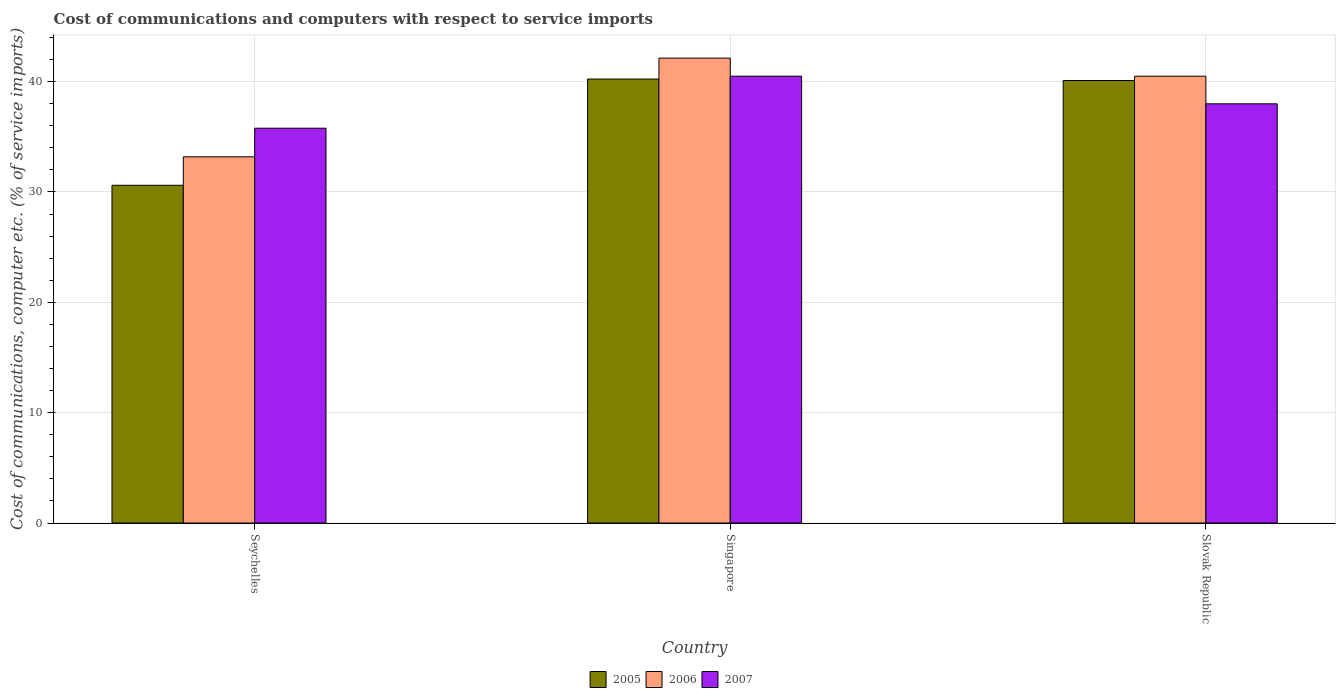How many bars are there on the 3rd tick from the left?
Offer a terse response. 3. How many bars are there on the 2nd tick from the right?
Offer a very short reply. 3. What is the label of the 3rd group of bars from the left?
Your response must be concise. Slovak Republic. What is the cost of communications and computers in 2006 in Singapore?
Your answer should be compact. 42.13. Across all countries, what is the maximum cost of communications and computers in 2005?
Make the answer very short. 40.24. Across all countries, what is the minimum cost of communications and computers in 2005?
Offer a very short reply. 30.61. In which country was the cost of communications and computers in 2007 maximum?
Offer a terse response. Singapore. In which country was the cost of communications and computers in 2007 minimum?
Ensure brevity in your answer.  Seychelles. What is the total cost of communications and computers in 2007 in the graph?
Your answer should be compact. 114.26. What is the difference between the cost of communications and computers in 2006 in Singapore and that in Slovak Republic?
Your answer should be compact. 1.64. What is the difference between the cost of communications and computers in 2005 in Slovak Republic and the cost of communications and computers in 2007 in Seychelles?
Provide a succinct answer. 4.32. What is the average cost of communications and computers in 2006 per country?
Your response must be concise. 38.6. What is the difference between the cost of communications and computers of/in 2007 and cost of communications and computers of/in 2005 in Seychelles?
Offer a very short reply. 5.17. What is the ratio of the cost of communications and computers in 2005 in Seychelles to that in Singapore?
Your answer should be very brief. 0.76. Is the cost of communications and computers in 2005 in Seychelles less than that in Singapore?
Offer a very short reply. Yes. Is the difference between the cost of communications and computers in 2007 in Seychelles and Slovak Republic greater than the difference between the cost of communications and computers in 2005 in Seychelles and Slovak Republic?
Your response must be concise. Yes. What is the difference between the highest and the second highest cost of communications and computers in 2005?
Offer a very short reply. 0.13. What is the difference between the highest and the lowest cost of communications and computers in 2007?
Keep it short and to the point. 4.71. Is the sum of the cost of communications and computers in 2007 in Singapore and Slovak Republic greater than the maximum cost of communications and computers in 2006 across all countries?
Provide a short and direct response. Yes. What does the 2nd bar from the left in Seychelles represents?
Offer a very short reply. 2006. What does the 3rd bar from the right in Seychelles represents?
Keep it short and to the point. 2005. Is it the case that in every country, the sum of the cost of communications and computers in 2005 and cost of communications and computers in 2007 is greater than the cost of communications and computers in 2006?
Offer a very short reply. Yes. How many bars are there?
Offer a terse response. 9. Does the graph contain any zero values?
Provide a short and direct response. No. How many legend labels are there?
Keep it short and to the point. 3. What is the title of the graph?
Keep it short and to the point. Cost of communications and computers with respect to service imports. Does "2005" appear as one of the legend labels in the graph?
Provide a short and direct response. Yes. What is the label or title of the X-axis?
Offer a very short reply. Country. What is the label or title of the Y-axis?
Provide a short and direct response. Cost of communications, computer etc. (% of service imports). What is the Cost of communications, computer etc. (% of service imports) of 2005 in Seychelles?
Provide a succinct answer. 30.61. What is the Cost of communications, computer etc. (% of service imports) of 2006 in Seychelles?
Keep it short and to the point. 33.19. What is the Cost of communications, computer etc. (% of service imports) of 2007 in Seychelles?
Your response must be concise. 35.78. What is the Cost of communications, computer etc. (% of service imports) in 2005 in Singapore?
Keep it short and to the point. 40.24. What is the Cost of communications, computer etc. (% of service imports) of 2006 in Singapore?
Your answer should be compact. 42.13. What is the Cost of communications, computer etc. (% of service imports) of 2007 in Singapore?
Keep it short and to the point. 40.49. What is the Cost of communications, computer etc. (% of service imports) in 2005 in Slovak Republic?
Provide a short and direct response. 40.1. What is the Cost of communications, computer etc. (% of service imports) in 2006 in Slovak Republic?
Make the answer very short. 40.49. What is the Cost of communications, computer etc. (% of service imports) in 2007 in Slovak Republic?
Your answer should be very brief. 37.99. Across all countries, what is the maximum Cost of communications, computer etc. (% of service imports) in 2005?
Your answer should be very brief. 40.24. Across all countries, what is the maximum Cost of communications, computer etc. (% of service imports) of 2006?
Offer a very short reply. 42.13. Across all countries, what is the maximum Cost of communications, computer etc. (% of service imports) in 2007?
Your answer should be very brief. 40.49. Across all countries, what is the minimum Cost of communications, computer etc. (% of service imports) of 2005?
Provide a short and direct response. 30.61. Across all countries, what is the minimum Cost of communications, computer etc. (% of service imports) of 2006?
Your answer should be compact. 33.19. Across all countries, what is the minimum Cost of communications, computer etc. (% of service imports) in 2007?
Keep it short and to the point. 35.78. What is the total Cost of communications, computer etc. (% of service imports) in 2005 in the graph?
Provide a short and direct response. 110.95. What is the total Cost of communications, computer etc. (% of service imports) in 2006 in the graph?
Your response must be concise. 115.81. What is the total Cost of communications, computer etc. (% of service imports) in 2007 in the graph?
Provide a succinct answer. 114.26. What is the difference between the Cost of communications, computer etc. (% of service imports) in 2005 in Seychelles and that in Singapore?
Your answer should be compact. -9.63. What is the difference between the Cost of communications, computer etc. (% of service imports) in 2006 in Seychelles and that in Singapore?
Your answer should be very brief. -8.94. What is the difference between the Cost of communications, computer etc. (% of service imports) in 2007 in Seychelles and that in Singapore?
Offer a terse response. -4.71. What is the difference between the Cost of communications, computer etc. (% of service imports) of 2005 in Seychelles and that in Slovak Republic?
Your answer should be compact. -9.49. What is the difference between the Cost of communications, computer etc. (% of service imports) in 2006 in Seychelles and that in Slovak Republic?
Offer a very short reply. -7.3. What is the difference between the Cost of communications, computer etc. (% of service imports) of 2007 in Seychelles and that in Slovak Republic?
Keep it short and to the point. -2.21. What is the difference between the Cost of communications, computer etc. (% of service imports) of 2005 in Singapore and that in Slovak Republic?
Your response must be concise. 0.13. What is the difference between the Cost of communications, computer etc. (% of service imports) in 2006 in Singapore and that in Slovak Republic?
Your answer should be very brief. 1.64. What is the difference between the Cost of communications, computer etc. (% of service imports) in 2007 in Singapore and that in Slovak Republic?
Your answer should be very brief. 2.5. What is the difference between the Cost of communications, computer etc. (% of service imports) of 2005 in Seychelles and the Cost of communications, computer etc. (% of service imports) of 2006 in Singapore?
Make the answer very short. -11.52. What is the difference between the Cost of communications, computer etc. (% of service imports) in 2005 in Seychelles and the Cost of communications, computer etc. (% of service imports) in 2007 in Singapore?
Keep it short and to the point. -9.89. What is the difference between the Cost of communications, computer etc. (% of service imports) of 2006 in Seychelles and the Cost of communications, computer etc. (% of service imports) of 2007 in Singapore?
Offer a terse response. -7.31. What is the difference between the Cost of communications, computer etc. (% of service imports) in 2005 in Seychelles and the Cost of communications, computer etc. (% of service imports) in 2006 in Slovak Republic?
Offer a very short reply. -9.88. What is the difference between the Cost of communications, computer etc. (% of service imports) of 2005 in Seychelles and the Cost of communications, computer etc. (% of service imports) of 2007 in Slovak Republic?
Keep it short and to the point. -7.38. What is the difference between the Cost of communications, computer etc. (% of service imports) in 2006 in Seychelles and the Cost of communications, computer etc. (% of service imports) in 2007 in Slovak Republic?
Your answer should be very brief. -4.8. What is the difference between the Cost of communications, computer etc. (% of service imports) of 2005 in Singapore and the Cost of communications, computer etc. (% of service imports) of 2006 in Slovak Republic?
Ensure brevity in your answer.  -0.25. What is the difference between the Cost of communications, computer etc. (% of service imports) in 2005 in Singapore and the Cost of communications, computer etc. (% of service imports) in 2007 in Slovak Republic?
Make the answer very short. 2.25. What is the difference between the Cost of communications, computer etc. (% of service imports) of 2006 in Singapore and the Cost of communications, computer etc. (% of service imports) of 2007 in Slovak Republic?
Your response must be concise. 4.14. What is the average Cost of communications, computer etc. (% of service imports) in 2005 per country?
Keep it short and to the point. 36.98. What is the average Cost of communications, computer etc. (% of service imports) in 2006 per country?
Your answer should be very brief. 38.6. What is the average Cost of communications, computer etc. (% of service imports) in 2007 per country?
Provide a short and direct response. 38.09. What is the difference between the Cost of communications, computer etc. (% of service imports) in 2005 and Cost of communications, computer etc. (% of service imports) in 2006 in Seychelles?
Ensure brevity in your answer.  -2.58. What is the difference between the Cost of communications, computer etc. (% of service imports) in 2005 and Cost of communications, computer etc. (% of service imports) in 2007 in Seychelles?
Ensure brevity in your answer.  -5.17. What is the difference between the Cost of communications, computer etc. (% of service imports) of 2006 and Cost of communications, computer etc. (% of service imports) of 2007 in Seychelles?
Keep it short and to the point. -2.59. What is the difference between the Cost of communications, computer etc. (% of service imports) of 2005 and Cost of communications, computer etc. (% of service imports) of 2006 in Singapore?
Provide a succinct answer. -1.89. What is the difference between the Cost of communications, computer etc. (% of service imports) of 2005 and Cost of communications, computer etc. (% of service imports) of 2007 in Singapore?
Keep it short and to the point. -0.26. What is the difference between the Cost of communications, computer etc. (% of service imports) of 2006 and Cost of communications, computer etc. (% of service imports) of 2007 in Singapore?
Keep it short and to the point. 1.64. What is the difference between the Cost of communications, computer etc. (% of service imports) of 2005 and Cost of communications, computer etc. (% of service imports) of 2006 in Slovak Republic?
Keep it short and to the point. -0.39. What is the difference between the Cost of communications, computer etc. (% of service imports) in 2005 and Cost of communications, computer etc. (% of service imports) in 2007 in Slovak Republic?
Give a very brief answer. 2.11. What is the difference between the Cost of communications, computer etc. (% of service imports) of 2006 and Cost of communications, computer etc. (% of service imports) of 2007 in Slovak Republic?
Provide a succinct answer. 2.5. What is the ratio of the Cost of communications, computer etc. (% of service imports) in 2005 in Seychelles to that in Singapore?
Provide a succinct answer. 0.76. What is the ratio of the Cost of communications, computer etc. (% of service imports) of 2006 in Seychelles to that in Singapore?
Provide a short and direct response. 0.79. What is the ratio of the Cost of communications, computer etc. (% of service imports) in 2007 in Seychelles to that in Singapore?
Offer a very short reply. 0.88. What is the ratio of the Cost of communications, computer etc. (% of service imports) of 2005 in Seychelles to that in Slovak Republic?
Offer a terse response. 0.76. What is the ratio of the Cost of communications, computer etc. (% of service imports) in 2006 in Seychelles to that in Slovak Republic?
Provide a succinct answer. 0.82. What is the ratio of the Cost of communications, computer etc. (% of service imports) in 2007 in Seychelles to that in Slovak Republic?
Ensure brevity in your answer.  0.94. What is the ratio of the Cost of communications, computer etc. (% of service imports) of 2005 in Singapore to that in Slovak Republic?
Provide a short and direct response. 1. What is the ratio of the Cost of communications, computer etc. (% of service imports) of 2006 in Singapore to that in Slovak Republic?
Provide a short and direct response. 1.04. What is the ratio of the Cost of communications, computer etc. (% of service imports) of 2007 in Singapore to that in Slovak Republic?
Provide a short and direct response. 1.07. What is the difference between the highest and the second highest Cost of communications, computer etc. (% of service imports) in 2005?
Offer a very short reply. 0.13. What is the difference between the highest and the second highest Cost of communications, computer etc. (% of service imports) of 2006?
Provide a succinct answer. 1.64. What is the difference between the highest and the second highest Cost of communications, computer etc. (% of service imports) of 2007?
Your answer should be very brief. 2.5. What is the difference between the highest and the lowest Cost of communications, computer etc. (% of service imports) in 2005?
Make the answer very short. 9.63. What is the difference between the highest and the lowest Cost of communications, computer etc. (% of service imports) in 2006?
Provide a succinct answer. 8.94. What is the difference between the highest and the lowest Cost of communications, computer etc. (% of service imports) of 2007?
Your response must be concise. 4.71. 